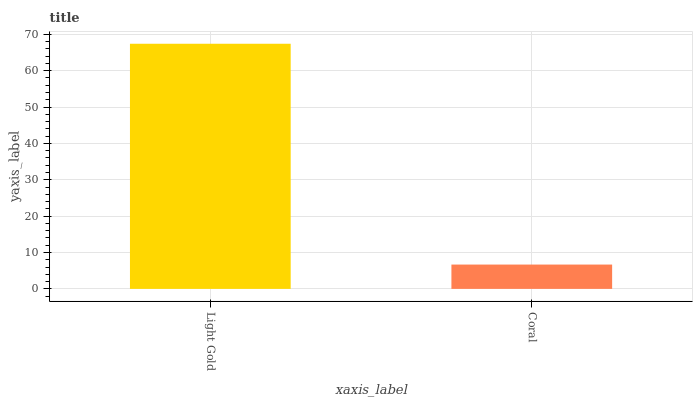Is Coral the minimum?
Answer yes or no. Yes. Is Light Gold the maximum?
Answer yes or no. Yes. Is Coral the maximum?
Answer yes or no. No. Is Light Gold greater than Coral?
Answer yes or no. Yes. Is Coral less than Light Gold?
Answer yes or no. Yes. Is Coral greater than Light Gold?
Answer yes or no. No. Is Light Gold less than Coral?
Answer yes or no. No. Is Light Gold the high median?
Answer yes or no. Yes. Is Coral the low median?
Answer yes or no. Yes. Is Coral the high median?
Answer yes or no. No. Is Light Gold the low median?
Answer yes or no. No. 